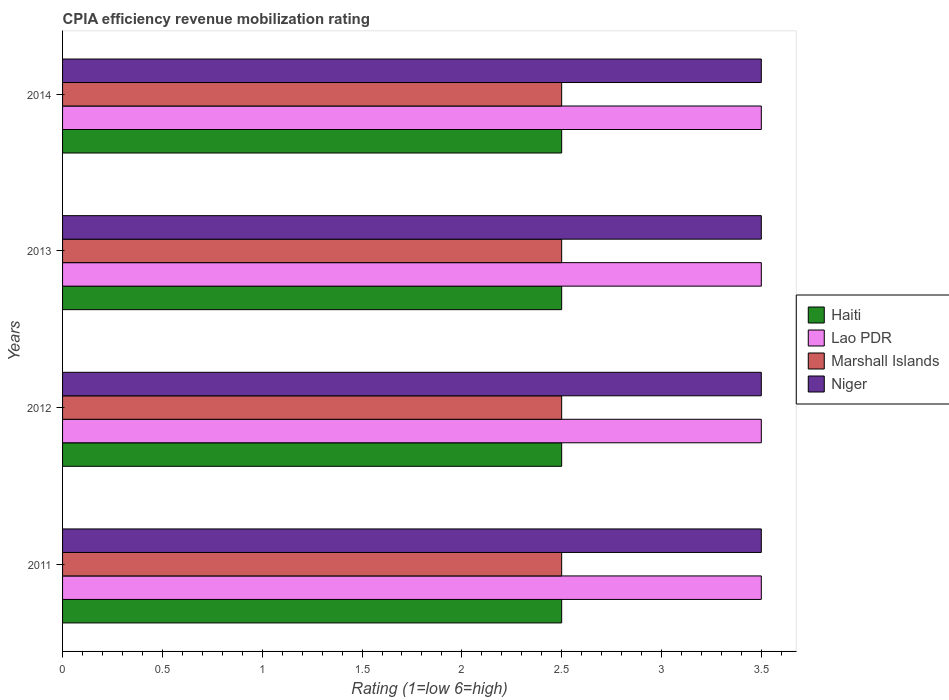What is the label of the 3rd group of bars from the top?
Offer a very short reply. 2012. In how many cases, is the number of bars for a given year not equal to the number of legend labels?
Make the answer very short. 0. What is the CPIA rating in Marshall Islands in 2013?
Provide a succinct answer. 2.5. Across all years, what is the minimum CPIA rating in Niger?
Offer a terse response. 3.5. What is the difference between the CPIA rating in Niger in 2011 and that in 2014?
Offer a very short reply. 0. What is the difference between the CPIA rating in Marshall Islands in 2011 and the CPIA rating in Lao PDR in 2014?
Offer a very short reply. -1. What is the average CPIA rating in Haiti per year?
Keep it short and to the point. 2.5. In how many years, is the CPIA rating in Marshall Islands greater than 1.5 ?
Offer a terse response. 4. Is the CPIA rating in Marshall Islands in 2012 less than that in 2013?
Provide a short and direct response. No. Is it the case that in every year, the sum of the CPIA rating in Haiti and CPIA rating in Marshall Islands is greater than the sum of CPIA rating in Lao PDR and CPIA rating in Niger?
Ensure brevity in your answer.  No. What does the 4th bar from the top in 2012 represents?
Your response must be concise. Haiti. What does the 4th bar from the bottom in 2012 represents?
Your answer should be very brief. Niger. Is it the case that in every year, the sum of the CPIA rating in Lao PDR and CPIA rating in Niger is greater than the CPIA rating in Haiti?
Offer a terse response. Yes. How many bars are there?
Keep it short and to the point. 16. Are all the bars in the graph horizontal?
Offer a very short reply. Yes. What is the difference between two consecutive major ticks on the X-axis?
Offer a very short reply. 0.5. Are the values on the major ticks of X-axis written in scientific E-notation?
Ensure brevity in your answer.  No. Does the graph contain grids?
Offer a very short reply. No. Where does the legend appear in the graph?
Provide a succinct answer. Center right. How many legend labels are there?
Provide a succinct answer. 4. What is the title of the graph?
Offer a very short reply. CPIA efficiency revenue mobilization rating. Does "Algeria" appear as one of the legend labels in the graph?
Your answer should be very brief. No. What is the label or title of the Y-axis?
Ensure brevity in your answer.  Years. What is the Rating (1=low 6=high) in Haiti in 2011?
Give a very brief answer. 2.5. What is the Rating (1=low 6=high) of Haiti in 2013?
Your answer should be very brief. 2.5. What is the Rating (1=low 6=high) in Niger in 2013?
Ensure brevity in your answer.  3.5. What is the Rating (1=low 6=high) in Haiti in 2014?
Your answer should be compact. 2.5. What is the Rating (1=low 6=high) in Lao PDR in 2014?
Provide a succinct answer. 3.5. What is the Rating (1=low 6=high) in Niger in 2014?
Provide a succinct answer. 3.5. Across all years, what is the maximum Rating (1=low 6=high) of Marshall Islands?
Your answer should be compact. 2.5. Across all years, what is the maximum Rating (1=low 6=high) of Niger?
Offer a terse response. 3.5. Across all years, what is the minimum Rating (1=low 6=high) in Haiti?
Your answer should be very brief. 2.5. Across all years, what is the minimum Rating (1=low 6=high) of Lao PDR?
Make the answer very short. 3.5. What is the total Rating (1=low 6=high) of Marshall Islands in the graph?
Offer a terse response. 10. What is the total Rating (1=low 6=high) of Niger in the graph?
Provide a succinct answer. 14. What is the difference between the Rating (1=low 6=high) of Haiti in 2011 and that in 2012?
Keep it short and to the point. 0. What is the difference between the Rating (1=low 6=high) of Lao PDR in 2011 and that in 2012?
Your answer should be compact. 0. What is the difference between the Rating (1=low 6=high) in Haiti in 2011 and that in 2013?
Give a very brief answer. 0. What is the difference between the Rating (1=low 6=high) in Marshall Islands in 2011 and that in 2014?
Ensure brevity in your answer.  0. What is the difference between the Rating (1=low 6=high) of Niger in 2011 and that in 2014?
Offer a very short reply. 0. What is the difference between the Rating (1=low 6=high) in Haiti in 2012 and that in 2013?
Offer a very short reply. 0. What is the difference between the Rating (1=low 6=high) of Lao PDR in 2012 and that in 2013?
Your answer should be very brief. 0. What is the difference between the Rating (1=low 6=high) of Lao PDR in 2012 and that in 2014?
Give a very brief answer. 0. What is the difference between the Rating (1=low 6=high) in Marshall Islands in 2012 and that in 2014?
Your answer should be compact. 0. What is the difference between the Rating (1=low 6=high) of Lao PDR in 2013 and that in 2014?
Offer a very short reply. 0. What is the difference between the Rating (1=low 6=high) in Marshall Islands in 2013 and that in 2014?
Your response must be concise. 0. What is the difference between the Rating (1=low 6=high) of Haiti in 2011 and the Rating (1=low 6=high) of Lao PDR in 2012?
Offer a terse response. -1. What is the difference between the Rating (1=low 6=high) in Lao PDR in 2011 and the Rating (1=low 6=high) in Marshall Islands in 2012?
Make the answer very short. 1. What is the difference between the Rating (1=low 6=high) of Marshall Islands in 2011 and the Rating (1=low 6=high) of Niger in 2012?
Ensure brevity in your answer.  -1. What is the difference between the Rating (1=low 6=high) in Lao PDR in 2011 and the Rating (1=low 6=high) in Marshall Islands in 2013?
Your answer should be very brief. 1. What is the difference between the Rating (1=low 6=high) of Lao PDR in 2011 and the Rating (1=low 6=high) of Niger in 2013?
Offer a terse response. 0. What is the difference between the Rating (1=low 6=high) of Marshall Islands in 2011 and the Rating (1=low 6=high) of Niger in 2013?
Provide a succinct answer. -1. What is the difference between the Rating (1=low 6=high) in Haiti in 2011 and the Rating (1=low 6=high) in Lao PDR in 2014?
Keep it short and to the point. -1. What is the difference between the Rating (1=low 6=high) of Haiti in 2011 and the Rating (1=low 6=high) of Marshall Islands in 2014?
Provide a succinct answer. 0. What is the difference between the Rating (1=low 6=high) of Haiti in 2011 and the Rating (1=low 6=high) of Niger in 2014?
Keep it short and to the point. -1. What is the difference between the Rating (1=low 6=high) of Lao PDR in 2011 and the Rating (1=low 6=high) of Marshall Islands in 2014?
Your response must be concise. 1. What is the difference between the Rating (1=low 6=high) in Haiti in 2012 and the Rating (1=low 6=high) in Marshall Islands in 2013?
Keep it short and to the point. 0. What is the difference between the Rating (1=low 6=high) of Lao PDR in 2012 and the Rating (1=low 6=high) of Marshall Islands in 2013?
Provide a short and direct response. 1. What is the difference between the Rating (1=low 6=high) of Marshall Islands in 2012 and the Rating (1=low 6=high) of Niger in 2013?
Provide a succinct answer. -1. What is the difference between the Rating (1=low 6=high) of Lao PDR in 2012 and the Rating (1=low 6=high) of Marshall Islands in 2014?
Offer a terse response. 1. What is the difference between the Rating (1=low 6=high) in Haiti in 2013 and the Rating (1=low 6=high) in Lao PDR in 2014?
Provide a short and direct response. -1. What is the difference between the Rating (1=low 6=high) of Haiti in 2013 and the Rating (1=low 6=high) of Niger in 2014?
Your answer should be compact. -1. What is the difference between the Rating (1=low 6=high) in Lao PDR in 2013 and the Rating (1=low 6=high) in Marshall Islands in 2014?
Keep it short and to the point. 1. What is the average Rating (1=low 6=high) in Haiti per year?
Give a very brief answer. 2.5. What is the average Rating (1=low 6=high) of Lao PDR per year?
Your answer should be compact. 3.5. In the year 2011, what is the difference between the Rating (1=low 6=high) in Haiti and Rating (1=low 6=high) in Lao PDR?
Make the answer very short. -1. In the year 2011, what is the difference between the Rating (1=low 6=high) in Lao PDR and Rating (1=low 6=high) in Niger?
Your response must be concise. 0. In the year 2011, what is the difference between the Rating (1=low 6=high) of Marshall Islands and Rating (1=low 6=high) of Niger?
Your answer should be very brief. -1. In the year 2012, what is the difference between the Rating (1=low 6=high) in Haiti and Rating (1=low 6=high) in Lao PDR?
Give a very brief answer. -1. In the year 2012, what is the difference between the Rating (1=low 6=high) of Lao PDR and Rating (1=low 6=high) of Marshall Islands?
Keep it short and to the point. 1. In the year 2012, what is the difference between the Rating (1=low 6=high) of Lao PDR and Rating (1=low 6=high) of Niger?
Your answer should be compact. 0. In the year 2012, what is the difference between the Rating (1=low 6=high) of Marshall Islands and Rating (1=low 6=high) of Niger?
Keep it short and to the point. -1. In the year 2013, what is the difference between the Rating (1=low 6=high) of Lao PDR and Rating (1=low 6=high) of Niger?
Keep it short and to the point. 0. In the year 2014, what is the difference between the Rating (1=low 6=high) of Haiti and Rating (1=low 6=high) of Lao PDR?
Provide a short and direct response. -1. In the year 2014, what is the difference between the Rating (1=low 6=high) in Haiti and Rating (1=low 6=high) in Marshall Islands?
Make the answer very short. 0. In the year 2014, what is the difference between the Rating (1=low 6=high) in Haiti and Rating (1=low 6=high) in Niger?
Give a very brief answer. -1. What is the ratio of the Rating (1=low 6=high) of Haiti in 2011 to that in 2012?
Provide a succinct answer. 1. What is the ratio of the Rating (1=low 6=high) of Lao PDR in 2011 to that in 2012?
Make the answer very short. 1. What is the ratio of the Rating (1=low 6=high) of Haiti in 2011 to that in 2013?
Keep it short and to the point. 1. What is the ratio of the Rating (1=low 6=high) in Lao PDR in 2011 to that in 2013?
Keep it short and to the point. 1. What is the ratio of the Rating (1=low 6=high) in Marshall Islands in 2011 to that in 2013?
Give a very brief answer. 1. What is the ratio of the Rating (1=low 6=high) of Lao PDR in 2011 to that in 2014?
Keep it short and to the point. 1. What is the ratio of the Rating (1=low 6=high) of Haiti in 2012 to that in 2013?
Offer a terse response. 1. What is the ratio of the Rating (1=low 6=high) of Lao PDR in 2012 to that in 2013?
Your answer should be very brief. 1. What is the ratio of the Rating (1=low 6=high) in Niger in 2012 to that in 2013?
Provide a succinct answer. 1. What is the ratio of the Rating (1=low 6=high) of Haiti in 2012 to that in 2014?
Offer a very short reply. 1. What is the ratio of the Rating (1=low 6=high) of Lao PDR in 2012 to that in 2014?
Your answer should be very brief. 1. What is the ratio of the Rating (1=low 6=high) in Marshall Islands in 2012 to that in 2014?
Your answer should be compact. 1. What is the ratio of the Rating (1=low 6=high) in Niger in 2012 to that in 2014?
Your answer should be very brief. 1. What is the ratio of the Rating (1=low 6=high) of Lao PDR in 2013 to that in 2014?
Provide a succinct answer. 1. What is the difference between the highest and the second highest Rating (1=low 6=high) in Lao PDR?
Your response must be concise. 0. What is the difference between the highest and the second highest Rating (1=low 6=high) of Niger?
Make the answer very short. 0. What is the difference between the highest and the lowest Rating (1=low 6=high) of Haiti?
Give a very brief answer. 0. What is the difference between the highest and the lowest Rating (1=low 6=high) of Lao PDR?
Provide a succinct answer. 0. What is the difference between the highest and the lowest Rating (1=low 6=high) of Marshall Islands?
Offer a terse response. 0. 